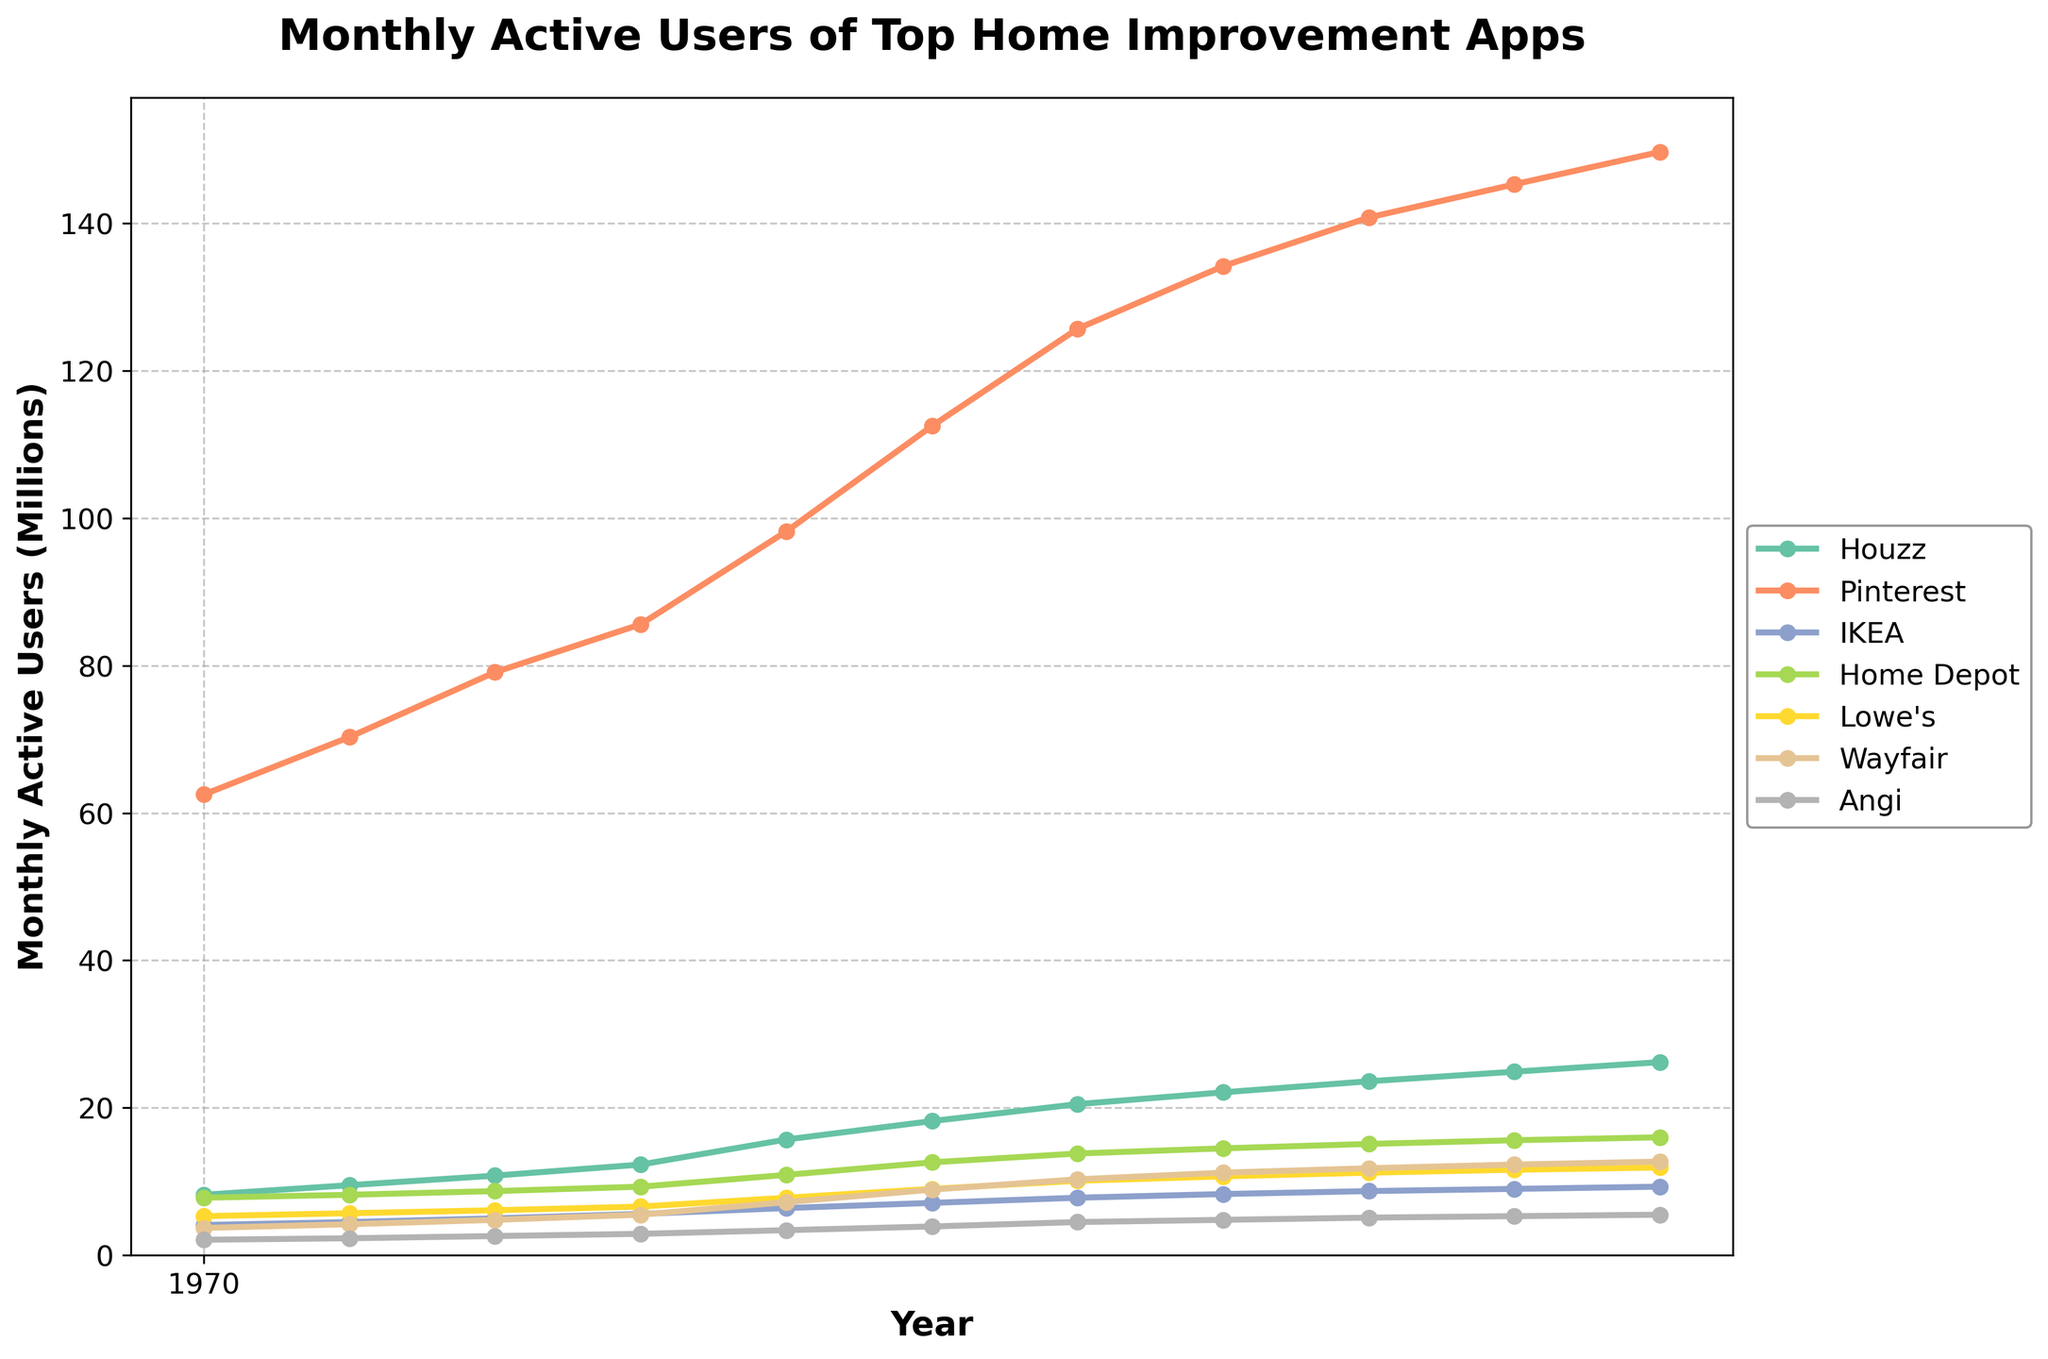What trend can you observe in the monthly active users of Houzz from 2018 to 2023? The monthly active users of Houzz are increasing consistently from 8.2 million in June 2018 to 26.2 million in June 2023.
Answer: Increasing Which app had the highest number of monthly active users in June 2020? By observing the figure, Pinterest had the highest number of monthly active users in June 2020 with 98.2 million users.
Answer: Pinterest How does the number of monthly active users for Lowe's in December 2022 compare to that of Wayfair? In December 2022, Lowe's had 11.6 million users, and Wayfair had 12.3 million users. Therefore, Wayfair had more users than Lowe's.
Answer: Wayfair had more What is the difference in the number of monthly active users between Home Depot and Angi in June 2021? In June 2021, Home Depot had 13.8 million users, and Angi had 4.5 million users. The difference is 13.8 - 4.5 = 9.3 million users.
Answer: 9.3 million Which app showed the most growth in monthly active users from June 2021 to June 2022? By observing the figure, Houzz increased from 20.5 million in June 2021 to 23.6 million in June 2022, a growth of 3.1 million. Other apps had less growth in this period.
Answer: Houzz Are there any instances where the monthly active users of any app decreased from one time period to the next? Observing the trends, no instances show a decrease in monthly active users for any app over the given time period.
Answer: No What's the average number of monthly active users for IKEA in December across all years shown? For December months (2018, 2019, 2020, 2021, 2022), the values are 4.5, 5.6, 7.1, 8.3, and 9.0. Average = (4.5 + 5.6 + 7.1 + 8.3 + 9.0) / 5 = 6.9 million.
Answer: 6.9 million How many apps had more than 10 million monthly active users in June 2023? By observing the figure, the apps with more than 10 million users in June 2023 are Pinterest, Houzz, IKEA, Home Depot, Lowe's, and Wayfair. There are 6 such apps.
Answer: 6 apps 